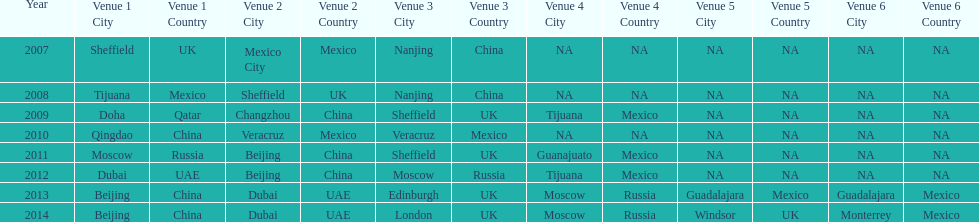In what year was the 3rd venue the same as 2011's 1st venue? 2012. 